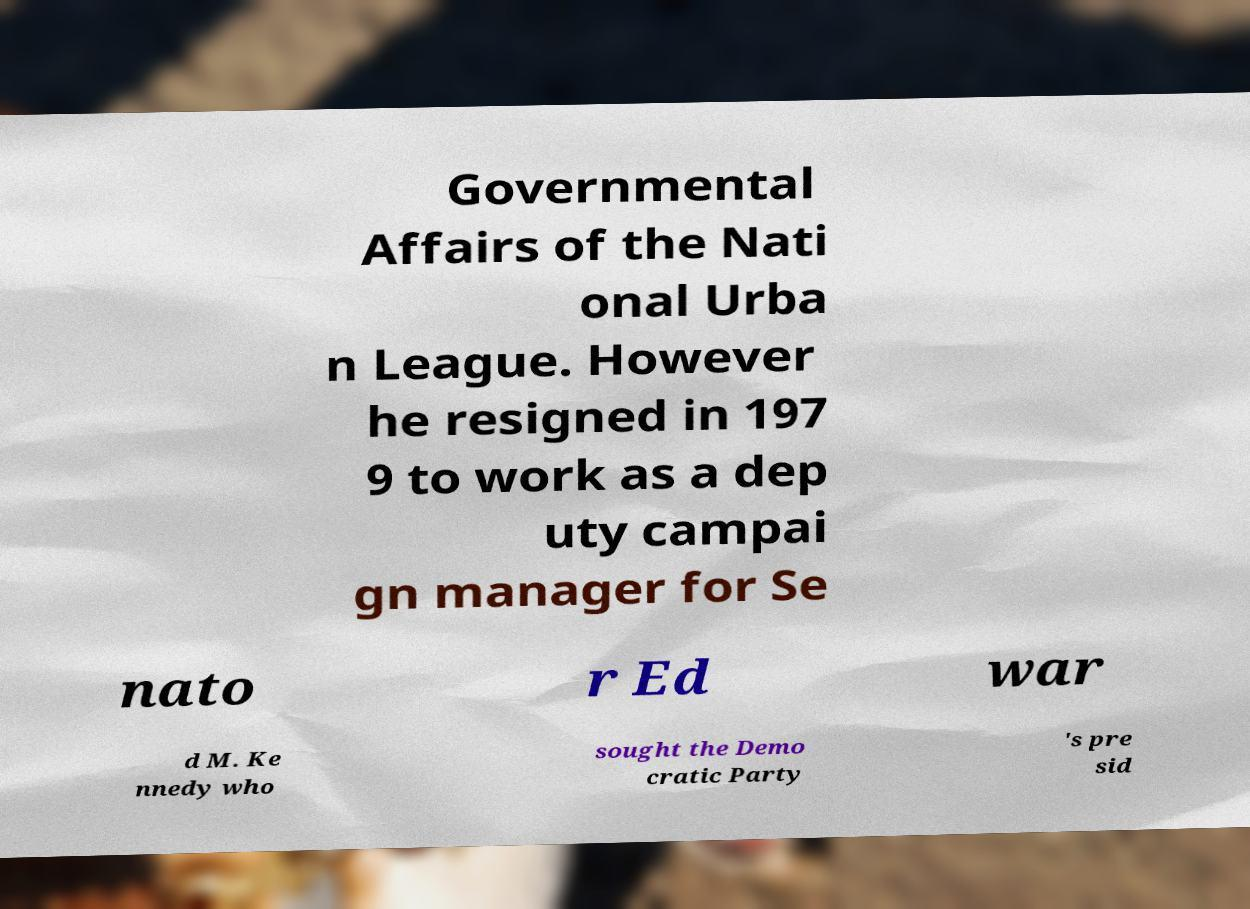Could you extract and type out the text from this image? Governmental Affairs of the Nati onal Urba n League. However he resigned in 197 9 to work as a dep uty campai gn manager for Se nato r Ed war d M. Ke nnedy who sought the Demo cratic Party 's pre sid 